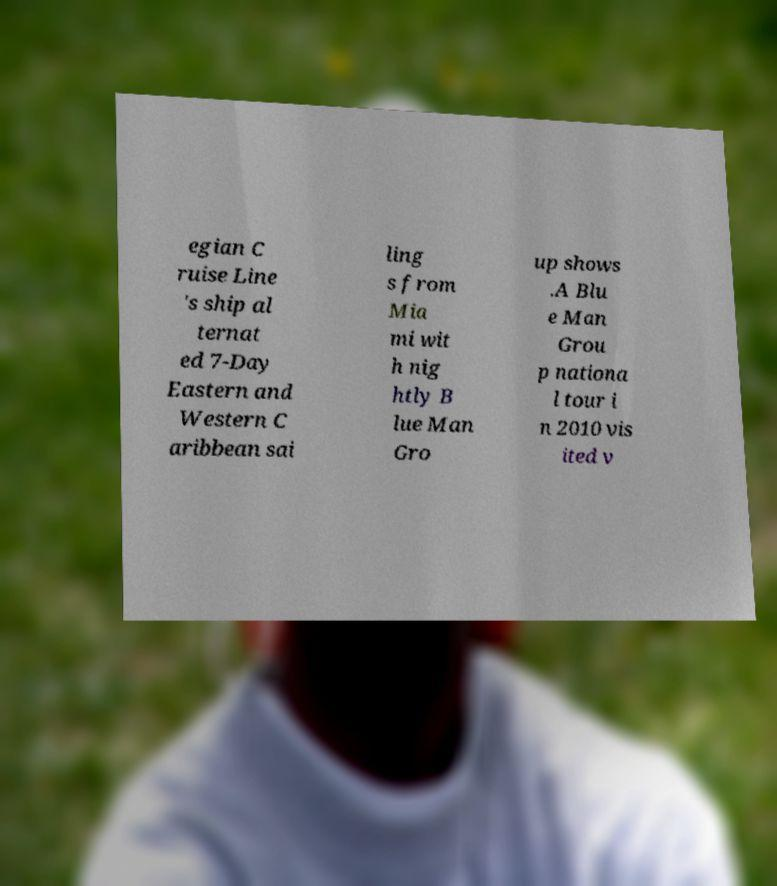Can you read and provide the text displayed in the image?This photo seems to have some interesting text. Can you extract and type it out for me? egian C ruise Line 's ship al ternat ed 7-Day Eastern and Western C aribbean sai ling s from Mia mi wit h nig htly B lue Man Gro up shows .A Blu e Man Grou p nationa l tour i n 2010 vis ited v 